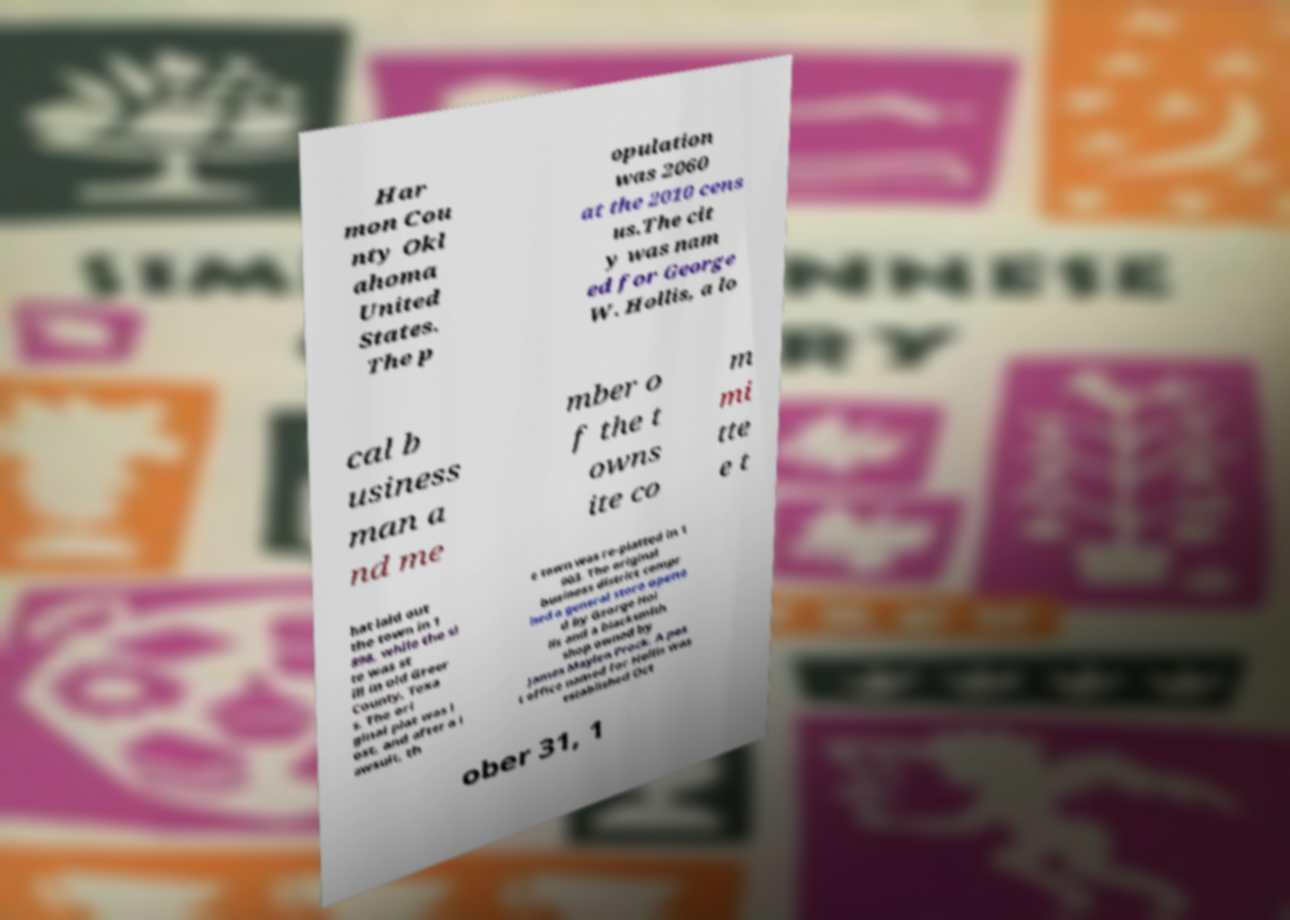Could you extract and type out the text from this image? Har mon Cou nty Okl ahoma United States. The p opulation was 2060 at the 2010 cens us.The cit y was nam ed for George W. Hollis, a lo cal b usiness man a nd me mber o f the t owns ite co m mi tte e t hat laid out the town in 1 898, while the si te was st ill in old Greer County, Texa s. The ori ginal plat was l ost, and after a l awsuit, th e town was re-platted in 1 903. The original business district compr ised a general store opene d by George Hol lis and a blacksmith shop owned by James Maylen Prock. A pos t office named for Hollis was established Oct ober 31, 1 